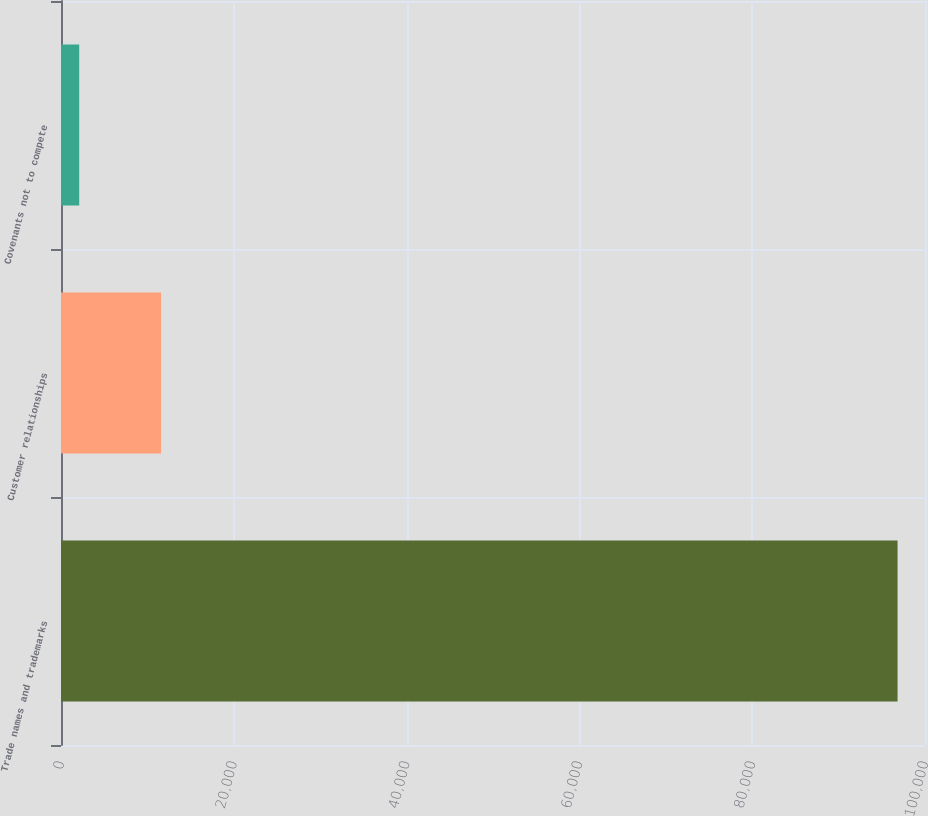Convert chart. <chart><loc_0><loc_0><loc_500><loc_500><bar_chart><fcel>Trade names and trademarks<fcel>Customer relationships<fcel>Covenants not to compete<nl><fcel>96823<fcel>11579.5<fcel>2108<nl></chart> 